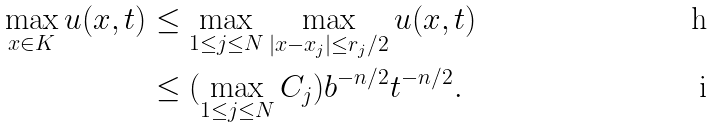Convert formula to latex. <formula><loc_0><loc_0><loc_500><loc_500>\max _ { x \in K } u ( x , t ) & \leq \max _ { 1 \leq j \leq N } \max _ { | x - x _ { j } | \leq r _ { j } / 2 } u ( x , t ) \\ & \leq ( \max _ { 1 \leq j \leq N } C _ { j } ) b ^ { - n / 2 } t ^ { - n / 2 } .</formula> 